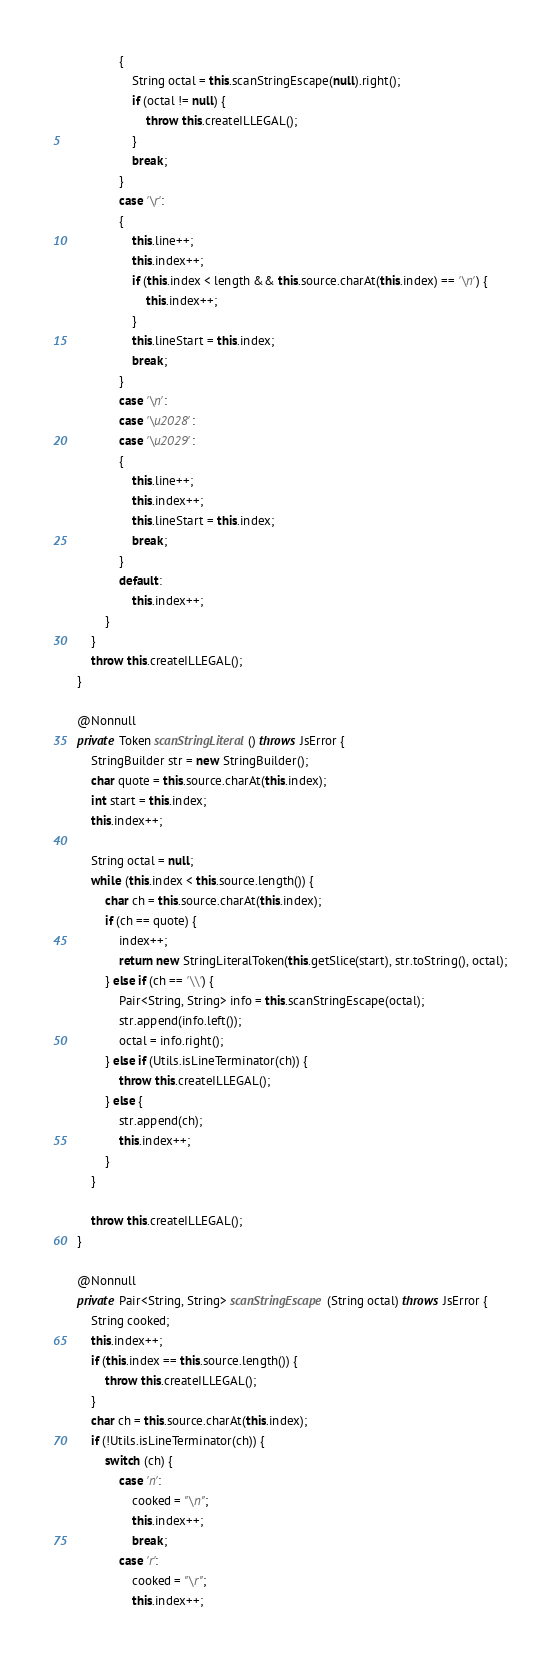Convert code to text. <code><loc_0><loc_0><loc_500><loc_500><_Java_>                {
                    String octal = this.scanStringEscape(null).right();
                    if (octal != null) {
                        throw this.createILLEGAL();
                    }
                    break;
                }
                case '\r':
                {
                    this.line++;
                    this.index++;
                    if (this.index < length && this.source.charAt(this.index) == '\n') {
                        this.index++;
                    }
                    this.lineStart = this.index;
                    break;
                }
                case '\n':
                case '\u2028':
                case '\u2029':
                {
                    this.line++;
                    this.index++;
                    this.lineStart = this.index;
                    break;
                }
                default:
                    this.index++;
            }
        }
        throw this.createILLEGAL();
    }

    @Nonnull
    private Token scanStringLiteral() throws JsError {
        StringBuilder str = new StringBuilder();
        char quote = this.source.charAt(this.index);
        int start = this.index;
        this.index++;

        String octal = null;
        while (this.index < this.source.length()) {
            char ch = this.source.charAt(this.index);
            if (ch == quote) {
                index++;
                return new StringLiteralToken(this.getSlice(start), str.toString(), octal);
            } else if (ch == '\\') {
                Pair<String, String> info = this.scanStringEscape(octal);
                str.append(info.left());
                octal = info.right();
            } else if (Utils.isLineTerminator(ch)) {
                throw this.createILLEGAL();
            } else {
                str.append(ch);
                this.index++;
            }
        }

        throw this.createILLEGAL();
    }

    @Nonnull
    private Pair<String, String> scanStringEscape(String octal) throws JsError {
        String cooked;
        this.index++;
        if (this.index == this.source.length()) {
            throw this.createILLEGAL();
        }
        char ch = this.source.charAt(this.index);
        if (!Utils.isLineTerminator(ch)) {
            switch (ch) {
                case 'n':
                    cooked = "\n";
                    this.index++;
                    break;
                case 'r':
                    cooked = "\r";
                    this.index++;</code> 